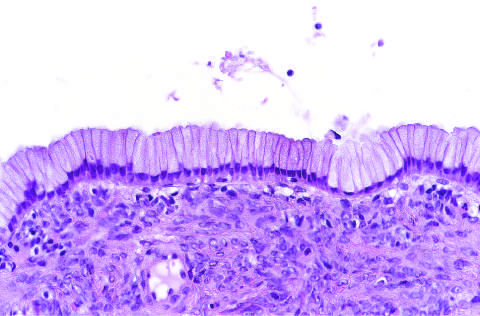re the cysts lined by columnar mucinous epithelium, with a densely cellular ovarian stroma?
Answer the question using a single word or phrase. Yes 